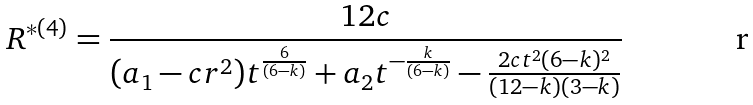Convert formula to latex. <formula><loc_0><loc_0><loc_500><loc_500>R ^ { * ( 4 ) } = \frac { 1 2 c } { ( a _ { 1 } - c r ^ { 2 } ) t ^ { \frac { 6 } { ( 6 - k ) } } + a _ { 2 } t ^ { - \frac { k } { ( 6 - k ) } } - \frac { 2 c t ^ { 2 } ( 6 - k ) ^ { 2 } } { ( 1 2 - k ) ( 3 - k ) } }</formula> 